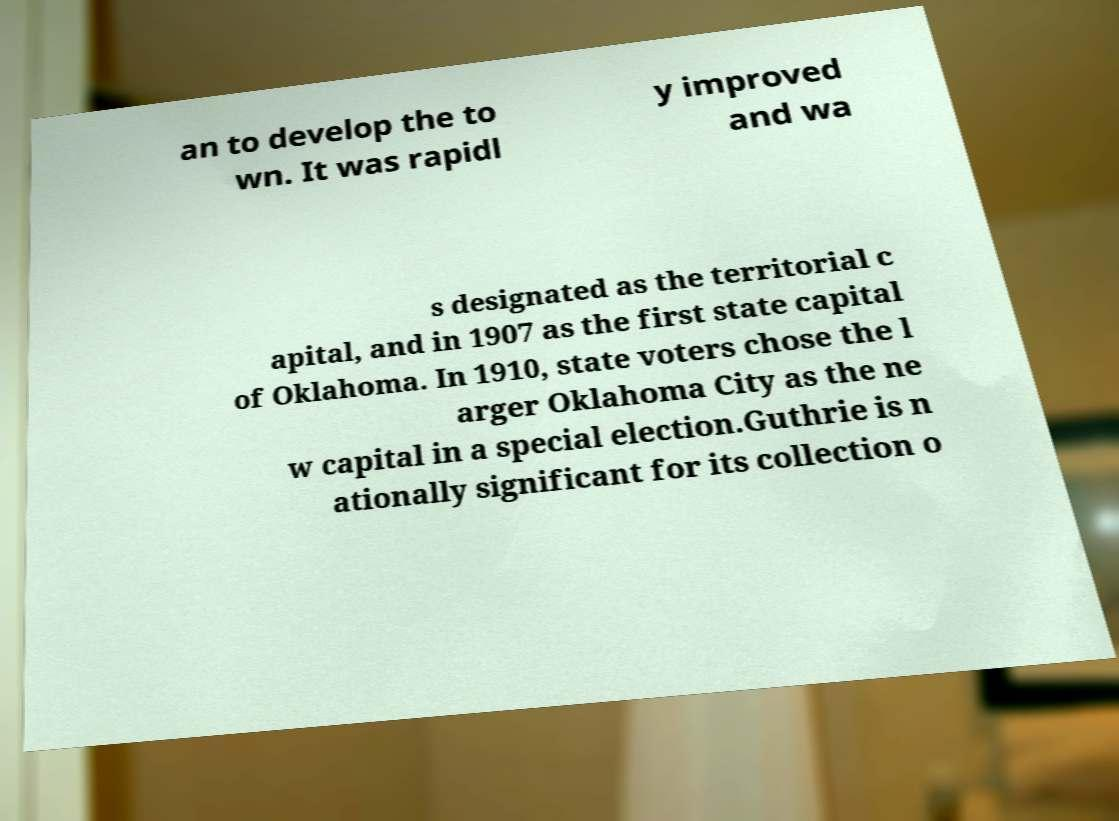Could you extract and type out the text from this image? an to develop the to wn. It was rapidl y improved and wa s designated as the territorial c apital, and in 1907 as the first state capital of Oklahoma. In 1910, state voters chose the l arger Oklahoma City as the ne w capital in a special election.Guthrie is n ationally significant for its collection o 